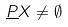<formula> <loc_0><loc_0><loc_500><loc_500>\underline { P } X \ne \emptyset</formula> 